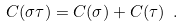<formula> <loc_0><loc_0><loc_500><loc_500>C ( \sigma \tau ) = C ( \sigma ) + C ( \tau ) \ . \\</formula> 